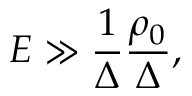Convert formula to latex. <formula><loc_0><loc_0><loc_500><loc_500>E \gg \frac { 1 } { \Delta } \frac { \rho _ { 0 } } { \Delta } ,</formula> 